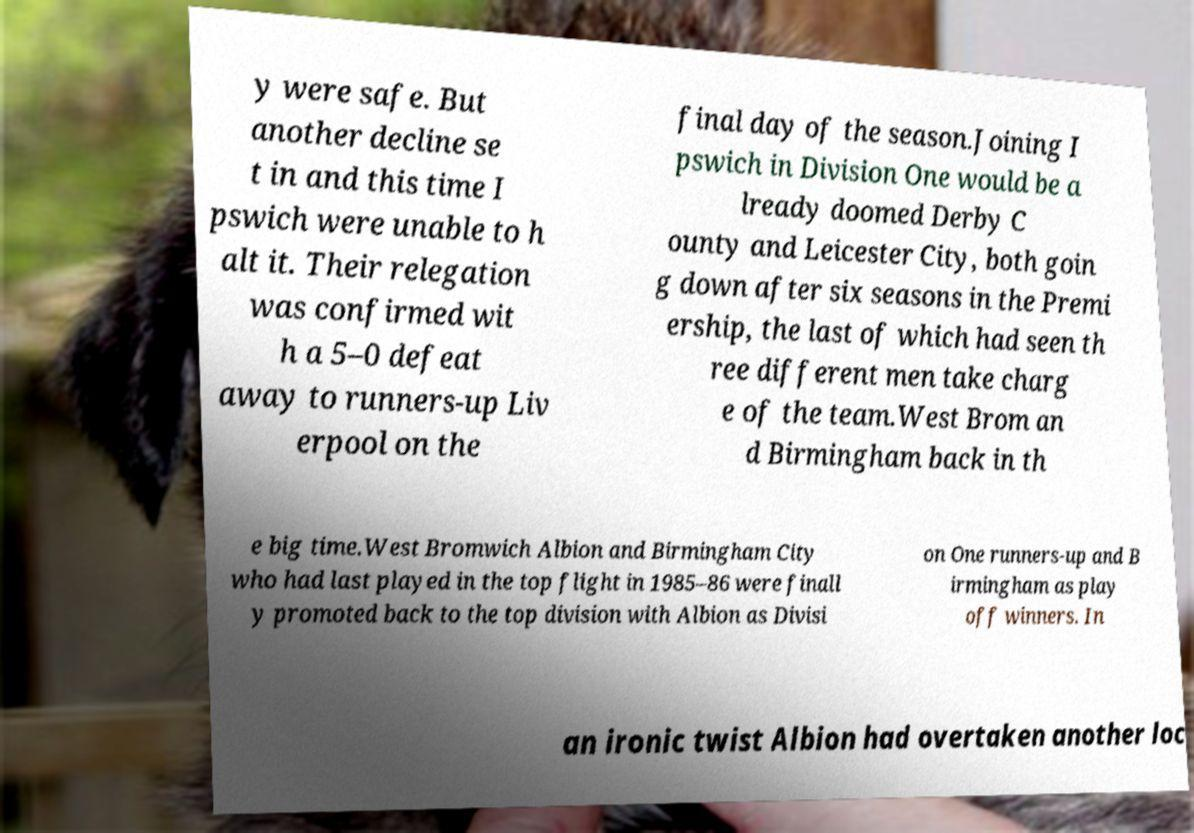I need the written content from this picture converted into text. Can you do that? y were safe. But another decline se t in and this time I pswich were unable to h alt it. Their relegation was confirmed wit h a 5–0 defeat away to runners-up Liv erpool on the final day of the season.Joining I pswich in Division One would be a lready doomed Derby C ounty and Leicester City, both goin g down after six seasons in the Premi ership, the last of which had seen th ree different men take charg e of the team.West Brom an d Birmingham back in th e big time.West Bromwich Albion and Birmingham City who had last played in the top flight in 1985–86 were finall y promoted back to the top division with Albion as Divisi on One runners-up and B irmingham as play off winners. In an ironic twist Albion had overtaken another loc 